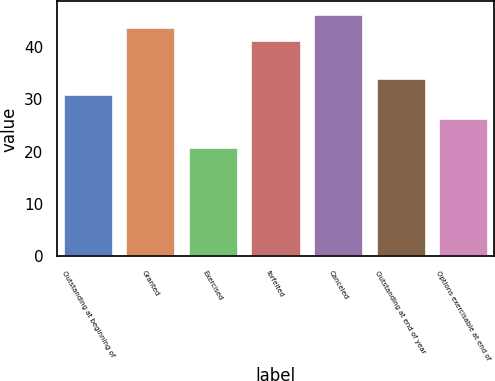Convert chart to OTSL. <chart><loc_0><loc_0><loc_500><loc_500><bar_chart><fcel>Outstanding at beginning of<fcel>Granted<fcel>Exercised<fcel>forfeited<fcel>Canceled<fcel>Outstanding at end of year<fcel>Options exercisable at end of<nl><fcel>31.04<fcel>43.81<fcel>20.85<fcel>41.29<fcel>46.33<fcel>34.07<fcel>26.49<nl></chart> 